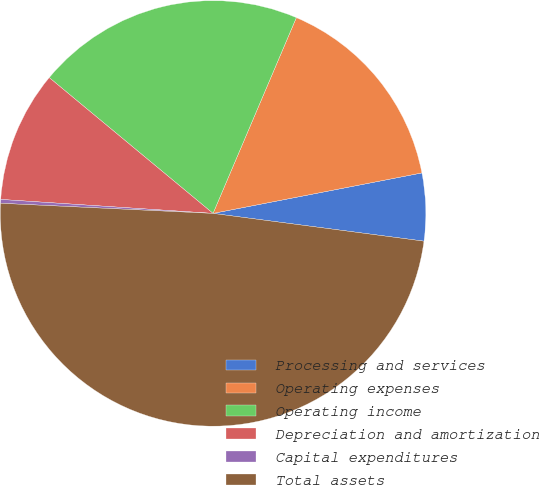Convert chart to OTSL. <chart><loc_0><loc_0><loc_500><loc_500><pie_chart><fcel>Processing and services<fcel>Operating expenses<fcel>Operating income<fcel>Depreciation and amortization<fcel>Capital expenditures<fcel>Total assets<nl><fcel>5.13%<fcel>15.55%<fcel>20.39%<fcel>9.97%<fcel>0.29%<fcel>48.68%<nl></chart> 